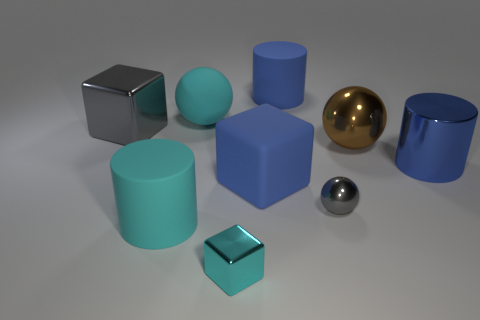Subtract all big spheres. How many spheres are left? 1 Subtract 1 cubes. How many cubes are left? 2 Add 1 small purple metal things. How many objects exist? 10 Subtract all blocks. How many objects are left? 6 Subtract all big matte balls. Subtract all cyan metal things. How many objects are left? 7 Add 9 big gray blocks. How many big gray blocks are left? 10 Add 6 tiny gray shiny objects. How many tiny gray shiny objects exist? 7 Subtract 0 green blocks. How many objects are left? 9 